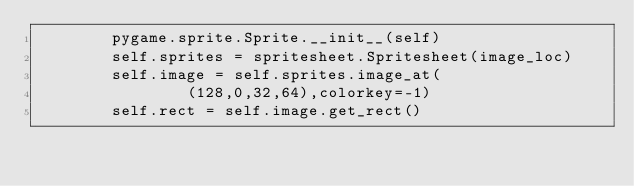Convert code to text. <code><loc_0><loc_0><loc_500><loc_500><_Python_>        pygame.sprite.Sprite.__init__(self)
        self.sprites = spritesheet.Spritesheet(image_loc)
        self.image = self.sprites.image_at(
                (128,0,32,64),colorkey=-1)
        self.rect = self.image.get_rect()</code> 